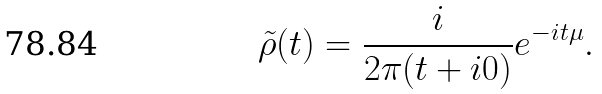Convert formula to latex. <formula><loc_0><loc_0><loc_500><loc_500>\tilde { \rho } ( t ) = \frac { i } { 2 \pi ( t + i 0 ) } e ^ { - i t \mu } .</formula> 